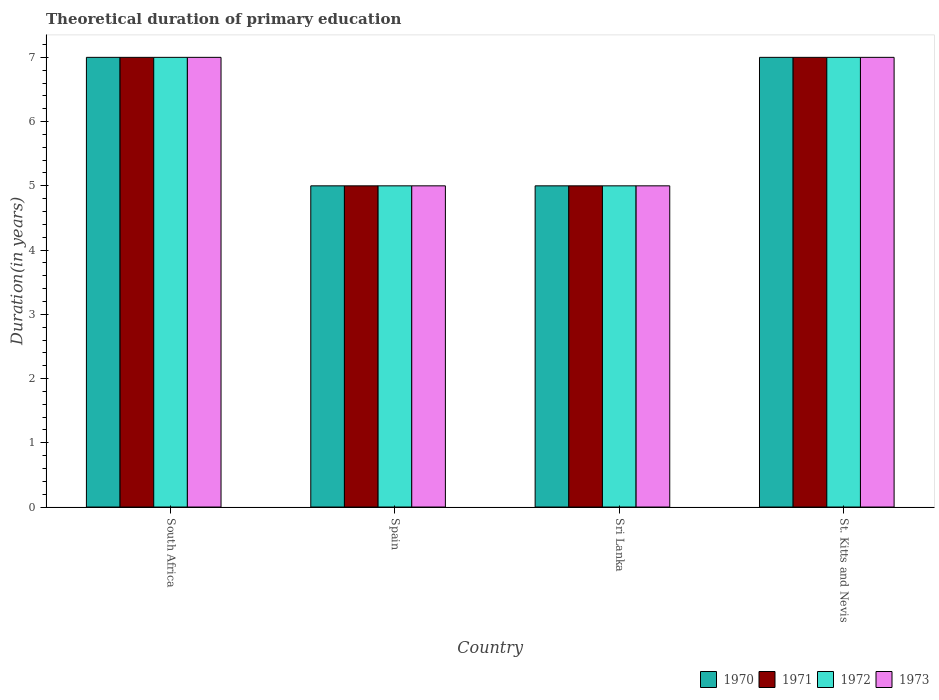How many groups of bars are there?
Offer a very short reply. 4. Are the number of bars per tick equal to the number of legend labels?
Give a very brief answer. Yes. How many bars are there on the 2nd tick from the left?
Your response must be concise. 4. What is the label of the 3rd group of bars from the left?
Offer a terse response. Sri Lanka. In how many cases, is the number of bars for a given country not equal to the number of legend labels?
Give a very brief answer. 0. Across all countries, what is the minimum total theoretical duration of primary education in 1972?
Your answer should be compact. 5. In which country was the total theoretical duration of primary education in 1972 maximum?
Give a very brief answer. South Africa. What is the total total theoretical duration of primary education in 1971 in the graph?
Your response must be concise. 24. What is the average total theoretical duration of primary education in 1971 per country?
Ensure brevity in your answer.  6. What is the difference between the total theoretical duration of primary education of/in 1972 and total theoretical duration of primary education of/in 1970 in Sri Lanka?
Ensure brevity in your answer.  0. What is the ratio of the total theoretical duration of primary education in 1973 in Spain to that in St. Kitts and Nevis?
Your answer should be very brief. 0.71. Is the total theoretical duration of primary education in 1970 in Spain less than that in Sri Lanka?
Give a very brief answer. No. Is the difference between the total theoretical duration of primary education in 1972 in Spain and St. Kitts and Nevis greater than the difference between the total theoretical duration of primary education in 1970 in Spain and St. Kitts and Nevis?
Make the answer very short. No. What is the difference between the highest and the second highest total theoretical duration of primary education in 1970?
Ensure brevity in your answer.  -2. What is the difference between the highest and the lowest total theoretical duration of primary education in 1971?
Ensure brevity in your answer.  2. In how many countries, is the total theoretical duration of primary education in 1971 greater than the average total theoretical duration of primary education in 1971 taken over all countries?
Your response must be concise. 2. What does the 2nd bar from the right in Sri Lanka represents?
Offer a very short reply. 1972. Is it the case that in every country, the sum of the total theoretical duration of primary education in 1970 and total theoretical duration of primary education in 1973 is greater than the total theoretical duration of primary education in 1972?
Your answer should be compact. Yes. How many bars are there?
Provide a succinct answer. 16. What is the difference between two consecutive major ticks on the Y-axis?
Provide a succinct answer. 1. Does the graph contain grids?
Make the answer very short. No. Where does the legend appear in the graph?
Your answer should be very brief. Bottom right. How many legend labels are there?
Offer a terse response. 4. How are the legend labels stacked?
Your response must be concise. Horizontal. What is the title of the graph?
Your response must be concise. Theoretical duration of primary education. Does "1990" appear as one of the legend labels in the graph?
Keep it short and to the point. No. What is the label or title of the X-axis?
Make the answer very short. Country. What is the label or title of the Y-axis?
Provide a succinct answer. Duration(in years). What is the Duration(in years) of 1970 in Spain?
Your answer should be very brief. 5. What is the Duration(in years) of 1971 in Spain?
Keep it short and to the point. 5. What is the Duration(in years) of 1973 in Spain?
Provide a short and direct response. 5. What is the Duration(in years) in 1970 in Sri Lanka?
Your answer should be very brief. 5. What is the Duration(in years) of 1973 in Sri Lanka?
Offer a very short reply. 5. What is the Duration(in years) in 1971 in St. Kitts and Nevis?
Ensure brevity in your answer.  7. What is the Duration(in years) of 1973 in St. Kitts and Nevis?
Your response must be concise. 7. Across all countries, what is the maximum Duration(in years) in 1971?
Make the answer very short. 7. Across all countries, what is the maximum Duration(in years) in 1972?
Give a very brief answer. 7. Across all countries, what is the maximum Duration(in years) in 1973?
Offer a very short reply. 7. Across all countries, what is the minimum Duration(in years) in 1971?
Offer a terse response. 5. What is the total Duration(in years) of 1970 in the graph?
Your response must be concise. 24. What is the total Duration(in years) of 1973 in the graph?
Your response must be concise. 24. What is the difference between the Duration(in years) of 1970 in South Africa and that in Sri Lanka?
Give a very brief answer. 2. What is the difference between the Duration(in years) in 1971 in South Africa and that in Sri Lanka?
Your answer should be very brief. 2. What is the difference between the Duration(in years) in 1972 in South Africa and that in Sri Lanka?
Keep it short and to the point. 2. What is the difference between the Duration(in years) in 1971 in South Africa and that in St. Kitts and Nevis?
Keep it short and to the point. 0. What is the difference between the Duration(in years) of 1970 in Spain and that in Sri Lanka?
Keep it short and to the point. 0. What is the difference between the Duration(in years) in 1971 in Spain and that in Sri Lanka?
Keep it short and to the point. 0. What is the difference between the Duration(in years) in 1972 in Spain and that in Sri Lanka?
Offer a terse response. 0. What is the difference between the Duration(in years) of 1970 in Spain and that in St. Kitts and Nevis?
Your response must be concise. -2. What is the difference between the Duration(in years) of 1972 in Spain and that in St. Kitts and Nevis?
Keep it short and to the point. -2. What is the difference between the Duration(in years) of 1971 in Sri Lanka and that in St. Kitts and Nevis?
Keep it short and to the point. -2. What is the difference between the Duration(in years) in 1973 in Sri Lanka and that in St. Kitts and Nevis?
Your answer should be compact. -2. What is the difference between the Duration(in years) in 1970 in South Africa and the Duration(in years) in 1971 in Spain?
Keep it short and to the point. 2. What is the difference between the Duration(in years) of 1970 in South Africa and the Duration(in years) of 1972 in Spain?
Provide a short and direct response. 2. What is the difference between the Duration(in years) in 1972 in South Africa and the Duration(in years) in 1973 in Spain?
Provide a succinct answer. 2. What is the difference between the Duration(in years) in 1970 in South Africa and the Duration(in years) in 1971 in Sri Lanka?
Give a very brief answer. 2. What is the difference between the Duration(in years) in 1970 in South Africa and the Duration(in years) in 1972 in Sri Lanka?
Offer a terse response. 2. What is the difference between the Duration(in years) of 1970 in South Africa and the Duration(in years) of 1973 in Sri Lanka?
Offer a very short reply. 2. What is the difference between the Duration(in years) in 1971 in South Africa and the Duration(in years) in 1973 in Sri Lanka?
Your response must be concise. 2. What is the difference between the Duration(in years) of 1970 in South Africa and the Duration(in years) of 1971 in St. Kitts and Nevis?
Ensure brevity in your answer.  0. What is the difference between the Duration(in years) of 1970 in South Africa and the Duration(in years) of 1972 in St. Kitts and Nevis?
Offer a very short reply. 0. What is the difference between the Duration(in years) in 1972 in South Africa and the Duration(in years) in 1973 in St. Kitts and Nevis?
Your answer should be compact. 0. What is the difference between the Duration(in years) of 1970 in Spain and the Duration(in years) of 1971 in Sri Lanka?
Provide a succinct answer. 0. What is the difference between the Duration(in years) in 1970 in Spain and the Duration(in years) in 1971 in St. Kitts and Nevis?
Provide a succinct answer. -2. What is the difference between the Duration(in years) in 1970 in Spain and the Duration(in years) in 1972 in St. Kitts and Nevis?
Your answer should be compact. -2. What is the difference between the Duration(in years) of 1970 in Spain and the Duration(in years) of 1973 in St. Kitts and Nevis?
Provide a succinct answer. -2. What is the difference between the Duration(in years) of 1971 in Spain and the Duration(in years) of 1972 in St. Kitts and Nevis?
Make the answer very short. -2. What is the difference between the Duration(in years) in 1972 in Spain and the Duration(in years) in 1973 in St. Kitts and Nevis?
Keep it short and to the point. -2. What is the difference between the Duration(in years) in 1970 in Sri Lanka and the Duration(in years) in 1973 in St. Kitts and Nevis?
Your answer should be very brief. -2. What is the difference between the Duration(in years) in 1972 in Sri Lanka and the Duration(in years) in 1973 in St. Kitts and Nevis?
Make the answer very short. -2. What is the average Duration(in years) of 1971 per country?
Offer a terse response. 6. What is the difference between the Duration(in years) in 1971 and Duration(in years) in 1973 in South Africa?
Make the answer very short. 0. What is the difference between the Duration(in years) of 1970 and Duration(in years) of 1972 in Spain?
Your response must be concise. 0. What is the difference between the Duration(in years) of 1971 and Duration(in years) of 1972 in Spain?
Ensure brevity in your answer.  0. What is the difference between the Duration(in years) of 1971 and Duration(in years) of 1973 in Spain?
Your answer should be compact. 0. What is the difference between the Duration(in years) of 1970 and Duration(in years) of 1971 in Sri Lanka?
Your answer should be compact. 0. What is the difference between the Duration(in years) in 1971 and Duration(in years) in 1972 in Sri Lanka?
Ensure brevity in your answer.  0. What is the difference between the Duration(in years) in 1971 and Duration(in years) in 1973 in Sri Lanka?
Make the answer very short. 0. What is the difference between the Duration(in years) of 1970 and Duration(in years) of 1972 in St. Kitts and Nevis?
Offer a very short reply. 0. What is the ratio of the Duration(in years) in 1971 in South Africa to that in Spain?
Ensure brevity in your answer.  1.4. What is the ratio of the Duration(in years) in 1970 in South Africa to that in Sri Lanka?
Offer a terse response. 1.4. What is the ratio of the Duration(in years) in 1972 in South Africa to that in Sri Lanka?
Ensure brevity in your answer.  1.4. What is the ratio of the Duration(in years) in 1973 in South Africa to that in Sri Lanka?
Provide a succinct answer. 1.4. What is the ratio of the Duration(in years) of 1971 in South Africa to that in St. Kitts and Nevis?
Your answer should be very brief. 1. What is the ratio of the Duration(in years) of 1973 in South Africa to that in St. Kitts and Nevis?
Your response must be concise. 1. What is the ratio of the Duration(in years) of 1971 in Spain to that in Sri Lanka?
Give a very brief answer. 1. What is the ratio of the Duration(in years) of 1972 in Spain to that in Sri Lanka?
Your answer should be compact. 1. What is the ratio of the Duration(in years) of 1970 in Spain to that in St. Kitts and Nevis?
Keep it short and to the point. 0.71. What is the ratio of the Duration(in years) of 1971 in Spain to that in St. Kitts and Nevis?
Provide a short and direct response. 0.71. What is the ratio of the Duration(in years) of 1972 in Spain to that in St. Kitts and Nevis?
Keep it short and to the point. 0.71. What is the ratio of the Duration(in years) of 1973 in Spain to that in St. Kitts and Nevis?
Ensure brevity in your answer.  0.71. What is the ratio of the Duration(in years) of 1971 in Sri Lanka to that in St. Kitts and Nevis?
Your response must be concise. 0.71. What is the ratio of the Duration(in years) in 1972 in Sri Lanka to that in St. Kitts and Nevis?
Ensure brevity in your answer.  0.71. What is the difference between the highest and the second highest Duration(in years) in 1971?
Give a very brief answer. 0. What is the difference between the highest and the second highest Duration(in years) in 1972?
Your answer should be compact. 0. What is the difference between the highest and the lowest Duration(in years) in 1971?
Provide a short and direct response. 2. What is the difference between the highest and the lowest Duration(in years) in 1972?
Your response must be concise. 2. 